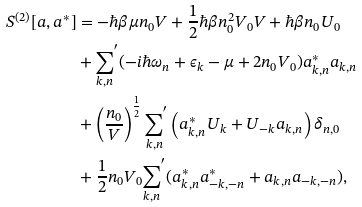<formula> <loc_0><loc_0><loc_500><loc_500>S ^ { ( 2 ) } [ a , a ^ { * } ] & = - \hbar { \beta } \mu n _ { 0 } V + \frac { 1 } { 2 } \hbar { \beta } n _ { 0 } ^ { 2 } V _ { 0 } V + \hbar { \beta } { n _ { 0 } } U _ { 0 } \\ & + { { \sum _ { { k } , n } } } ^ { ^ { \prime } } ( - i \hbar { \omega } _ { n } + \epsilon _ { k } - \mu + 2 n _ { 0 } V _ { 0 } ) a ^ { * } _ { { k } , n } a _ { { k } , n } \\ & + \left ( \frac { n _ { 0 } } { V } \right ) ^ { \frac { 1 } { 2 } } { \sum _ { { k } , n } } ^ { ^ { \prime } } \left ( a _ { { k } , n } ^ { * } U _ { k } + U _ { - { k } } a _ { { k } , n } \right ) \delta _ { n , 0 } \\ & + \frac { 1 } { 2 } n _ { 0 } V _ { 0 } { \sum _ { { k } , n } } ^ { ^ { \prime } } ( a ^ { * } _ { { k } , n } a ^ { * } _ { { - k } , - n } + a _ { { k } , n } a _ { { - k } , - n } ) ,</formula> 